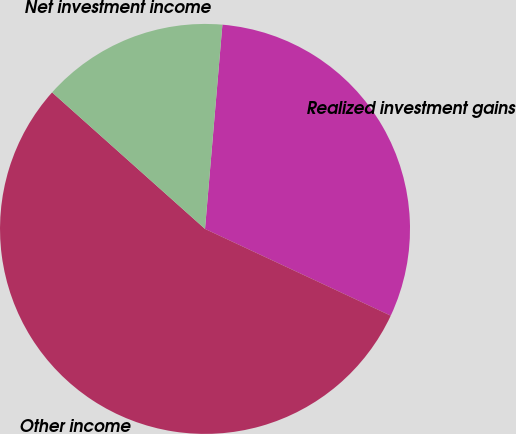Convert chart. <chart><loc_0><loc_0><loc_500><loc_500><pie_chart><fcel>Realized investment gains<fcel>Other income<fcel>Net investment income<nl><fcel>30.6%<fcel>54.64%<fcel>14.75%<nl></chart> 